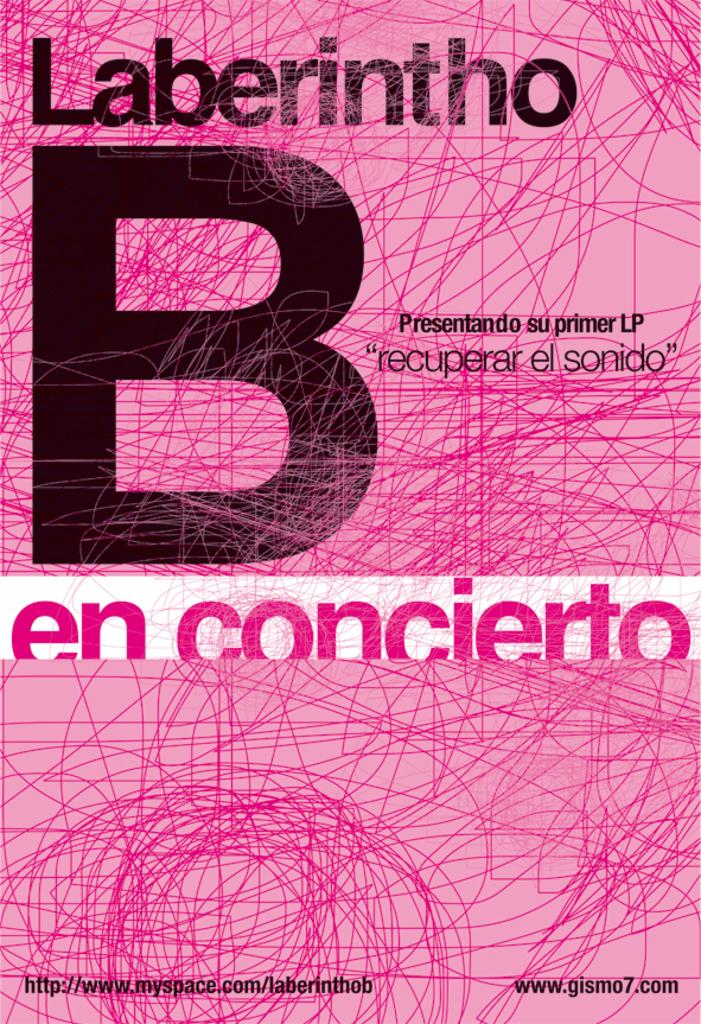<image>
Summarize the visual content of the image. Cover for Laberintho B en concierto with a pink background. 